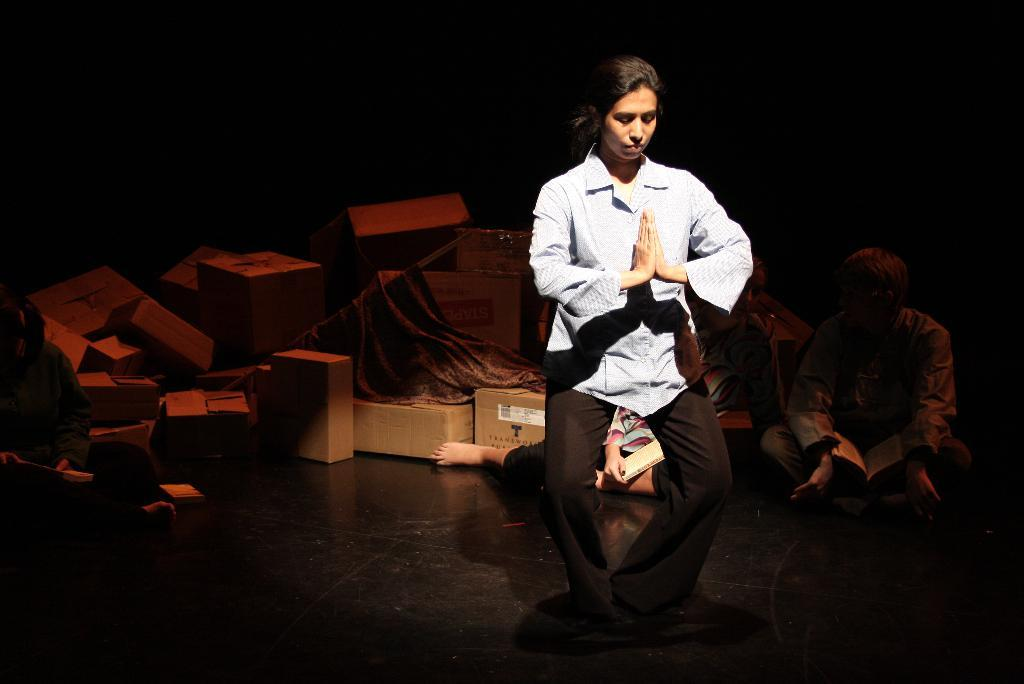What is the main subject of the image? The main subject of the image is a woman standing and giving a pose. Can you describe the people in the background of the image? There are three persons sitting in the background of the image. What else can be seen in the image besides the woman and the people in the background? There are boxes visible in the image. How many houses are visible in the image? There are no houses visible in the image. What is the distance between the woman and the people sitting in the background? The distance between the woman and the people sitting in the background cannot be determined from the image alone. --- Facts: 1. There is a car in the image. 2. The car is parked on the street. 3. There are trees on both sides of the street. 4. The sky is visible in the image. Absurd Topics: animals, ocean, mountain Conversation: What is the main subject of the image? The main subject of the image is a car. Where is the car located in the image? The car is parked on the street. What can be seen on both sides of the street in the image? There are trees on both sides of the street. What is visible in the background of the image? The sky is visible in the image. Reasoning: Let's think step by step in order to produce the conversation. We start by identifying the main subject of the image, which is the car. Then, we describe the location of the car, noting that it is parked on the street. Next, we mention the presence of trees on both sides of the street, which adds more detail to the context to the scene. Finally, we describe the background, which is the sky. Absurd Question/Answer: Can you see any animals in the image? There are no animals visible in the image. Is there an ocean visible in the image? There is no ocean visible in the image. 